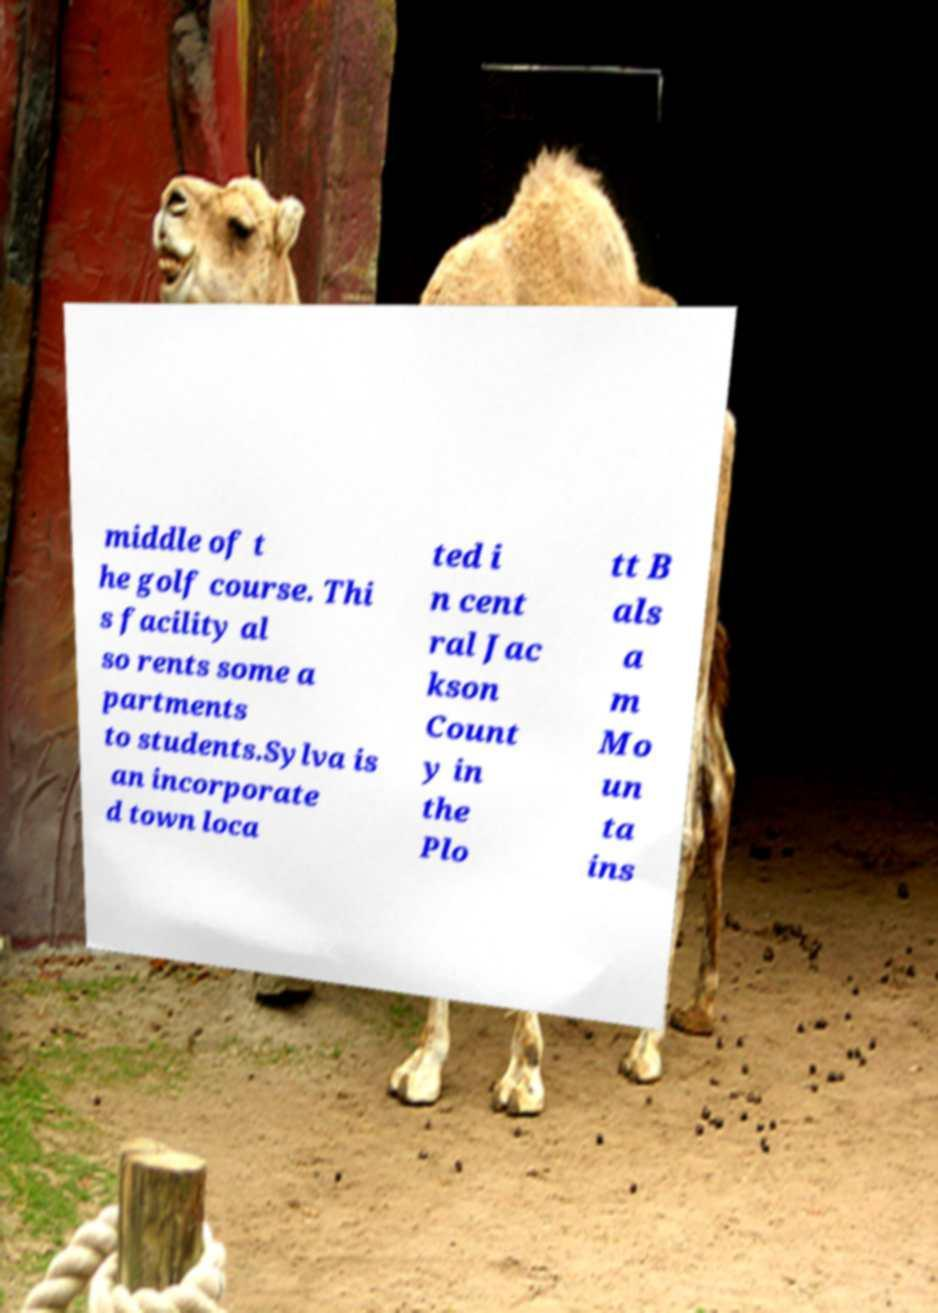Can you read and provide the text displayed in the image?This photo seems to have some interesting text. Can you extract and type it out for me? middle of t he golf course. Thi s facility al so rents some a partments to students.Sylva is an incorporate d town loca ted i n cent ral Jac kson Count y in the Plo tt B als a m Mo un ta ins 